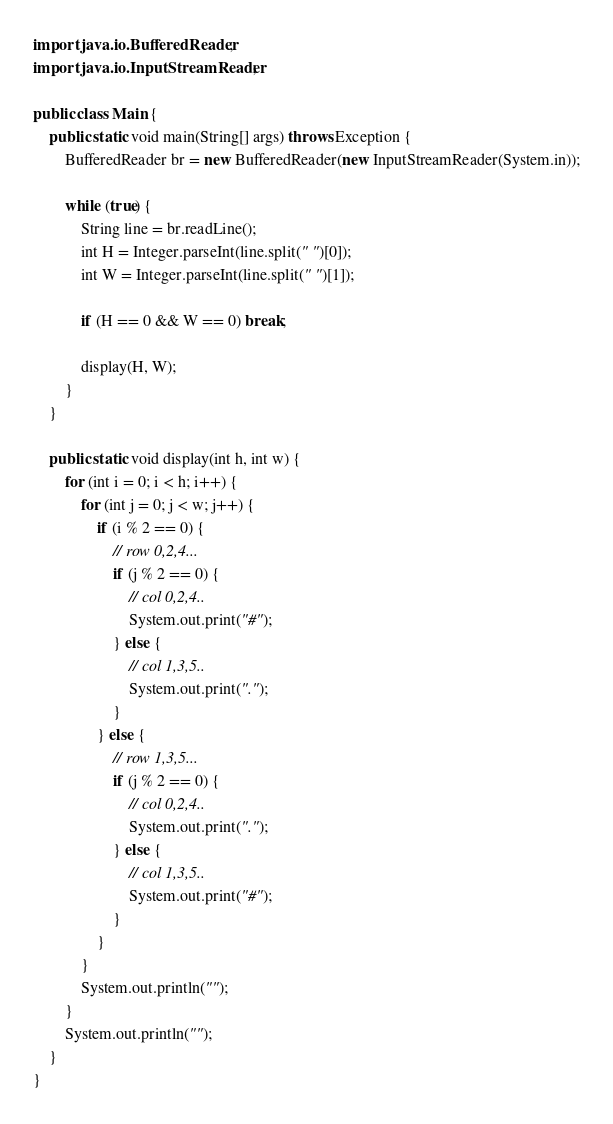Convert code to text. <code><loc_0><loc_0><loc_500><loc_500><_Java_>import java.io.BufferedReader;
import java.io.InputStreamReader;

public class Main {
	public static void main(String[] args) throws Exception {
		BufferedReader br = new BufferedReader(new InputStreamReader(System.in));

	    while (true) {
		    String line = br.readLine();
		    int H = Integer.parseInt(line.split(" ")[0]);
		    int W = Integer.parseInt(line.split(" ")[1]);

		    if (H == 0 && W == 0) break;

		    display(H, W);
	    }
	}

	public static void display(int h, int w) {
		for (int i = 0; i < h; i++) {
			for (int j = 0; j < w; j++) {
				if (i % 2 == 0) {
					// row 0,2,4...
					if (j % 2 == 0) {
						// col 0,2,4..
						System.out.print("#");
					} else {
						// col 1,3,5..
						System.out.print(".");
					}
				} else {
					// row 1,3,5...
					if (j % 2 == 0) {
						// col 0,2,4..
						System.out.print(".");
					} else {
						// col 1,3,5..
						System.out.print("#");
					}
				}
			}
			System.out.println("");
		}
		System.out.println("");
	}
}</code> 